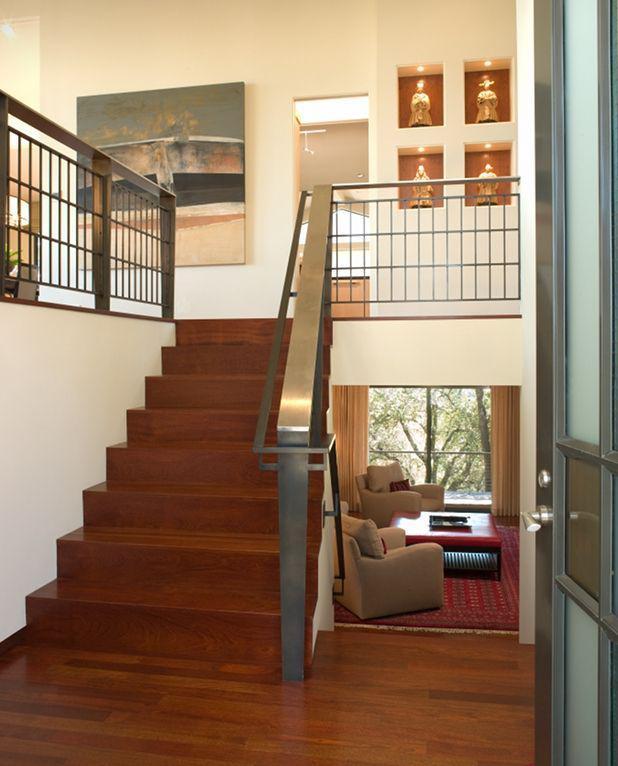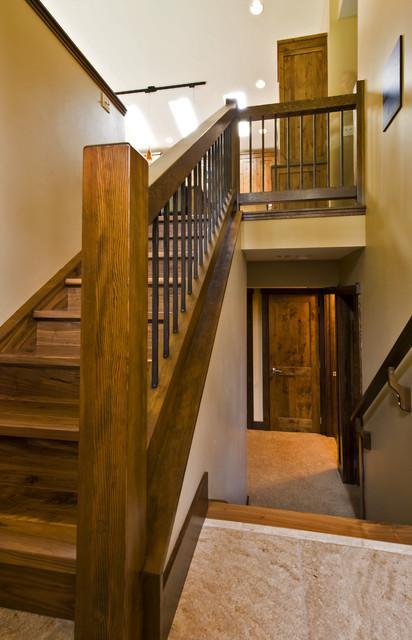The first image is the image on the left, the second image is the image on the right. For the images displayed, is the sentence "IN at least one image there is at least one sofa chair to the side of a staircase on the first floor." factually correct? Answer yes or no. Yes. The first image is the image on the left, the second image is the image on the right. Examine the images to the left and right. Is the description "An image shows a view down a staircase that leads to a door shape, and a flat ledge is at the left instead of a flight of stairs." accurate? Answer yes or no. No. 